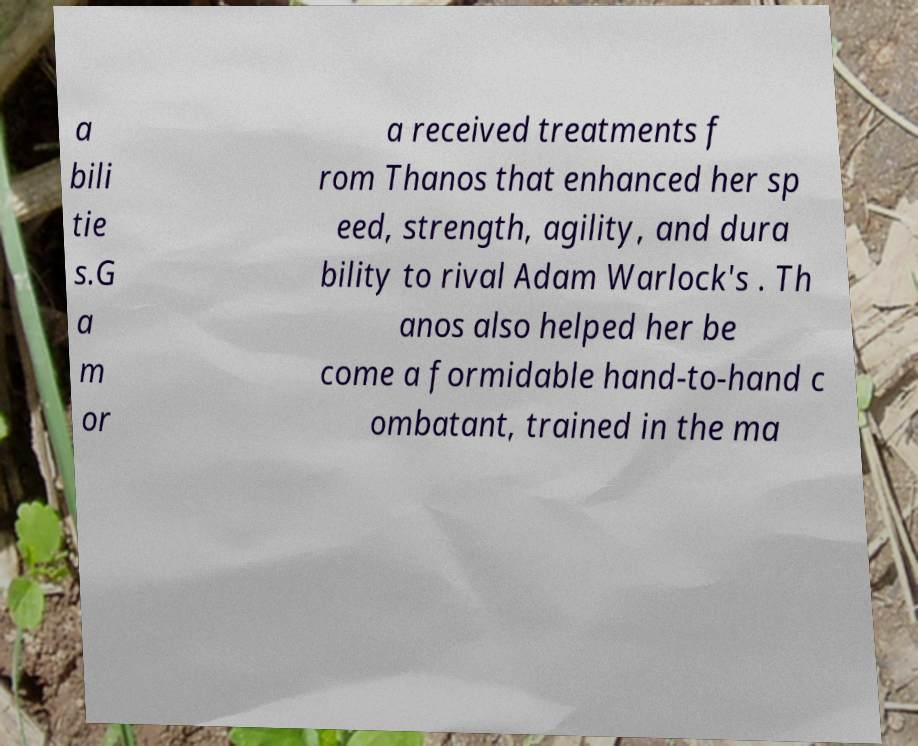Could you extract and type out the text from this image? a bili tie s.G a m or a received treatments f rom Thanos that enhanced her sp eed, strength, agility, and dura bility to rival Adam Warlock's . Th anos also helped her be come a formidable hand-to-hand c ombatant, trained in the ma 